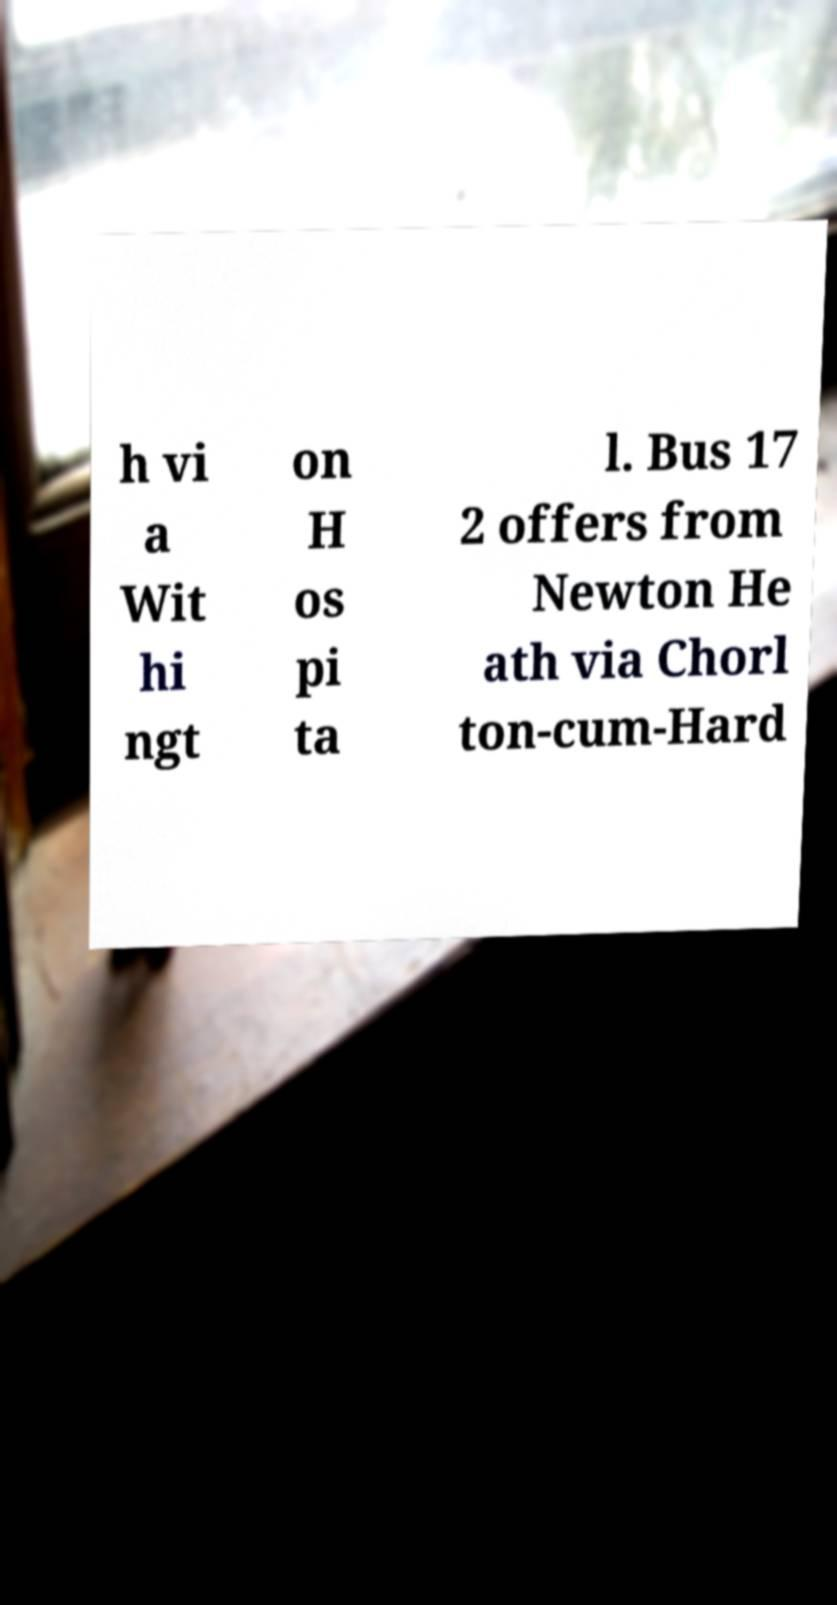Could you assist in decoding the text presented in this image and type it out clearly? h vi a Wit hi ngt on H os pi ta l. Bus 17 2 offers from Newton He ath via Chorl ton-cum-Hard 